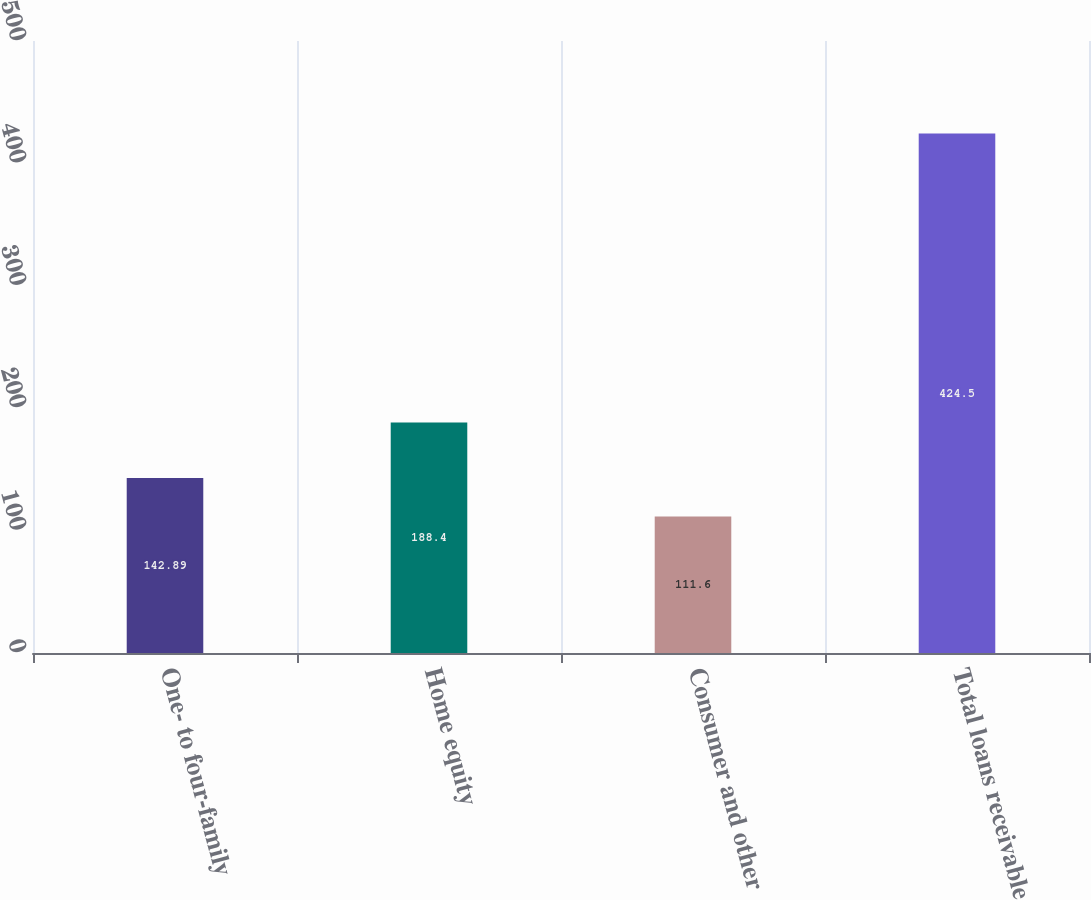Convert chart. <chart><loc_0><loc_0><loc_500><loc_500><bar_chart><fcel>One- to four-family<fcel>Home equity<fcel>Consumer and other<fcel>Total loans receivable<nl><fcel>142.89<fcel>188.4<fcel>111.6<fcel>424.5<nl></chart> 